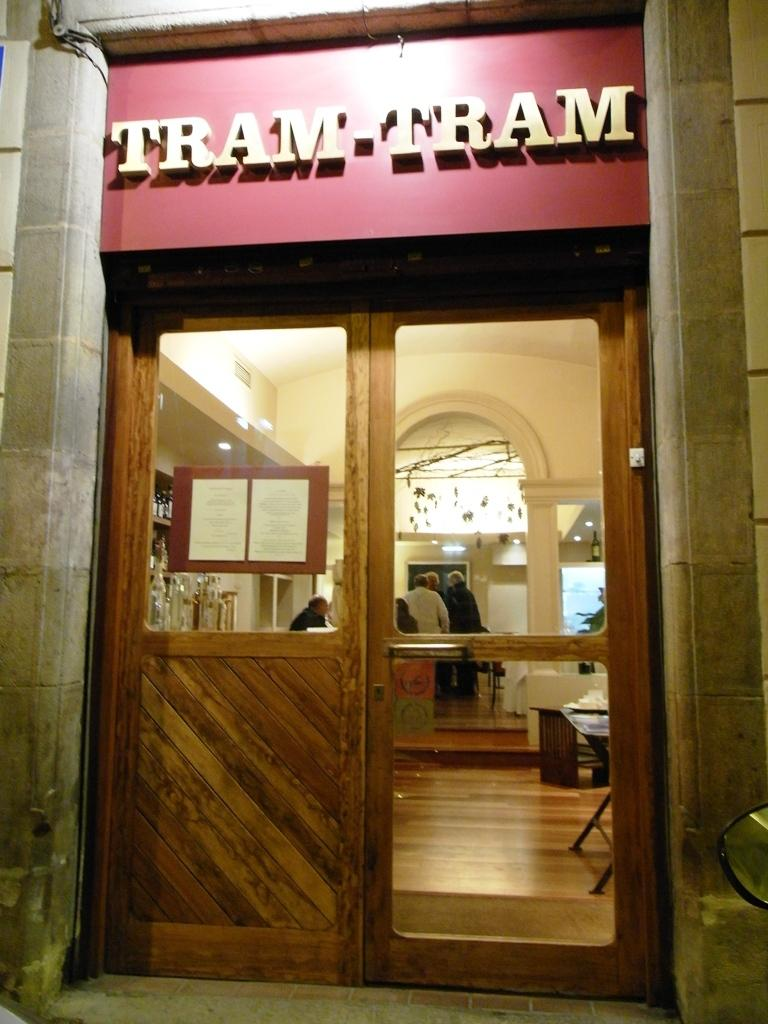What is the main object in the image? There is a door in the image. What is written or depicted on the door? There is text on the door. Can you describe the setting or environment in the image? There are people in the background of the image. Is there a coach carrying a cub in the rain in the image? No, there is no coach, cub, or rain present in the image. The image only features a door with text and people in the background. 